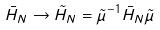<formula> <loc_0><loc_0><loc_500><loc_500>\bar { H } _ { N } \rightarrow \tilde { H } _ { N } = \tilde { \mu } ^ { - 1 } \bar { H } _ { N } \tilde { \mu }</formula> 